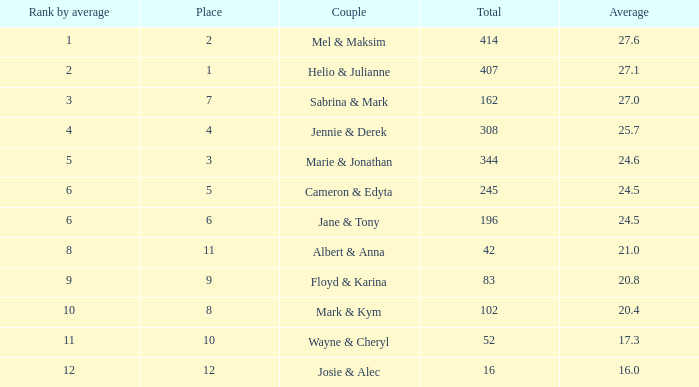What is the average when the rank by average is more than 12? None. 